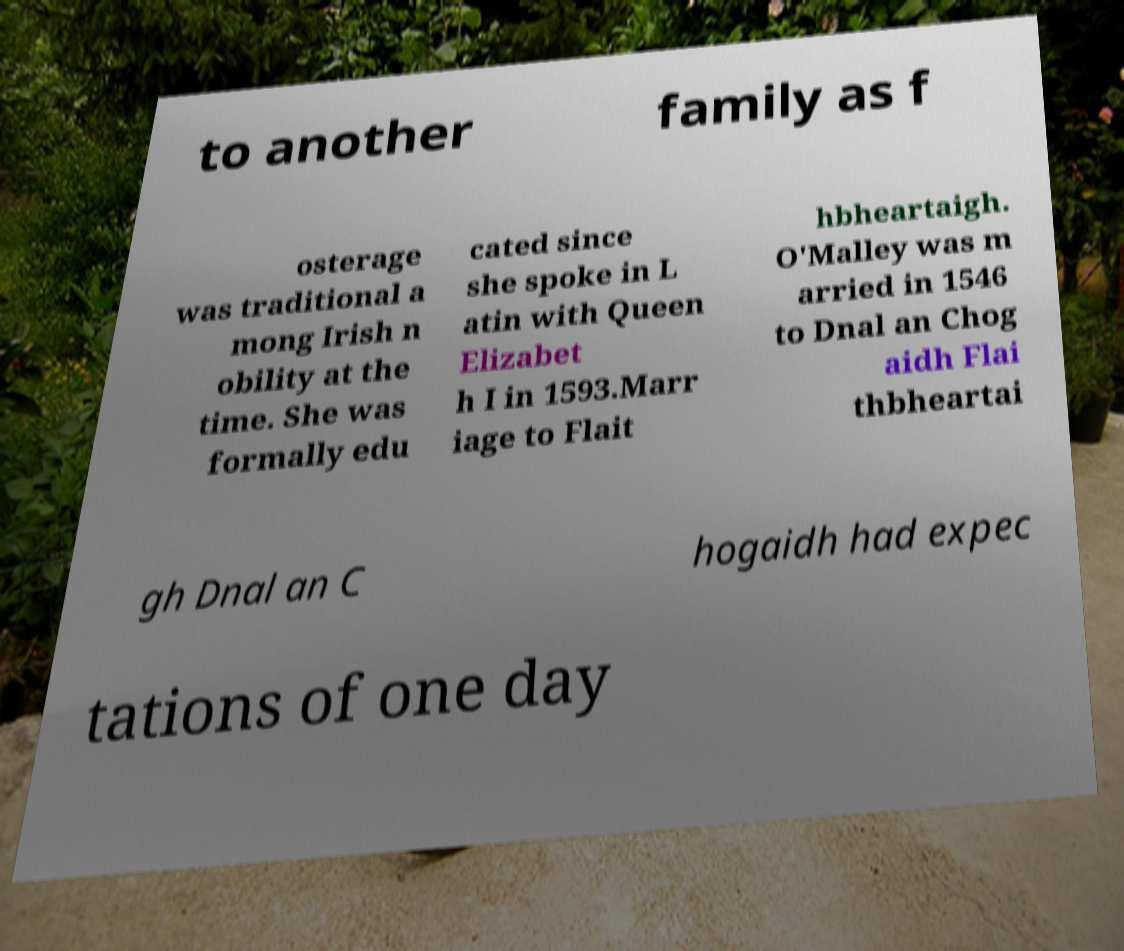I need the written content from this picture converted into text. Can you do that? to another family as f osterage was traditional a mong Irish n obility at the time. She was formally edu cated since she spoke in L atin with Queen Elizabet h I in 1593.Marr iage to Flait hbheartaigh. O'Malley was m arried in 1546 to Dnal an Chog aidh Flai thbheartai gh Dnal an C hogaidh had expec tations of one day 